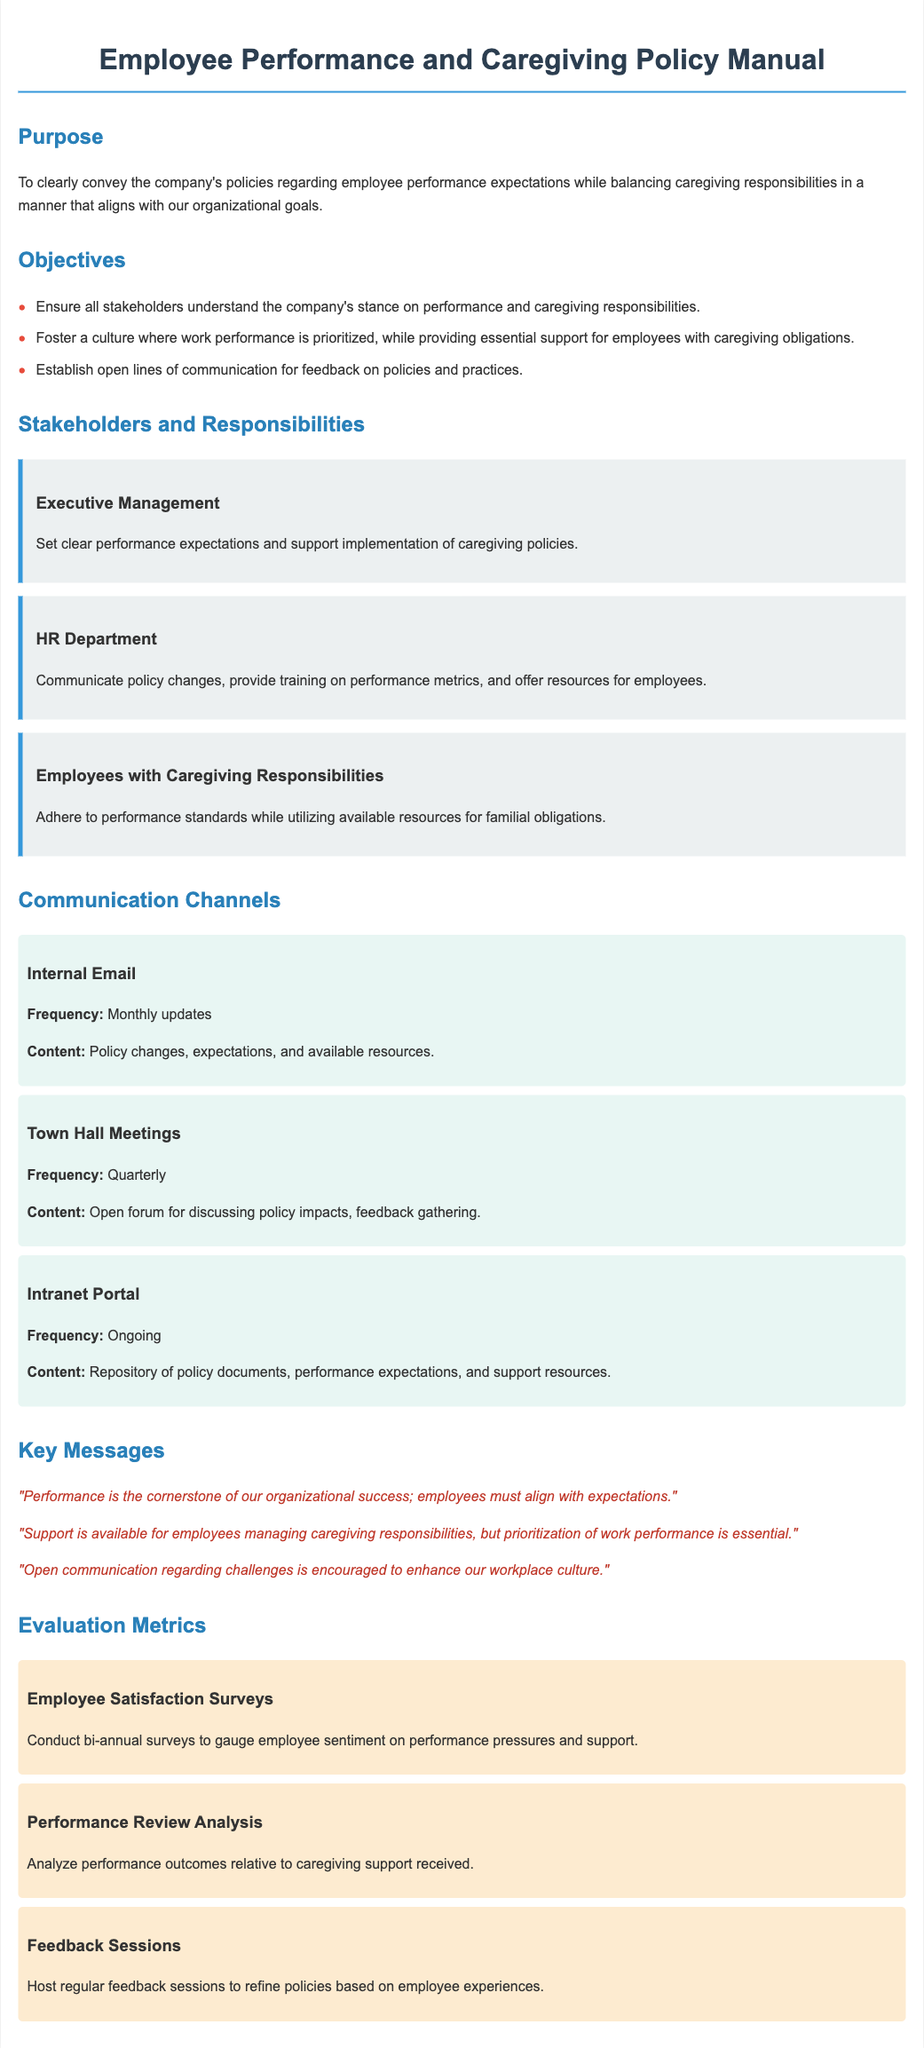What is the purpose of the manual? The purpose is stated clearly at the beginning, as it conveys the company's policies regarding employee performance expectations while balancing caregiving responsibilities.
Answer: To clearly convey the company's policies regarding employee performance expectations while balancing caregiving responsibilities in a manner that aligns with our organizational goals How often are Town Hall Meetings held? The frequency of Town Hall Meetings is provided under the communication channels section.
Answer: Quarterly Who is responsible for communicating policy changes? The responsibilities of the HR Department regarding communication are outlined in the stakeholder section.
Answer: HR Department What is the frequency of Employee Satisfaction Surveys? The frequency for conducting employee satisfaction surveys is detailed in the evaluation metrics section.
Answer: Bi-annual What is a key message regarding employee performance? One of the key messages emphasizes the importance of performance in the organization.
Answer: "Performance is the cornerstone of our organizational success; employees must align with expectations." What type of feedback sessions are held regularly? The document describes the nature of the feedback sessions in the evaluation metrics section.
Answer: Regular feedback sessions What should employees with caregiving responsibilities adhere to? The responsibilities of employees with caregiving obligations are mentioned in the stakeholder section.
Answer: Performance standards Which group sets clear performance expectations? The role of Executive Management in setting performance expectations is outlined in the stakeholder section.
Answer: Executive Management What content is shared through internal email? The communication content for internal email is specified in the communication channels section.
Answer: Policy changes, expectations, and available resources 